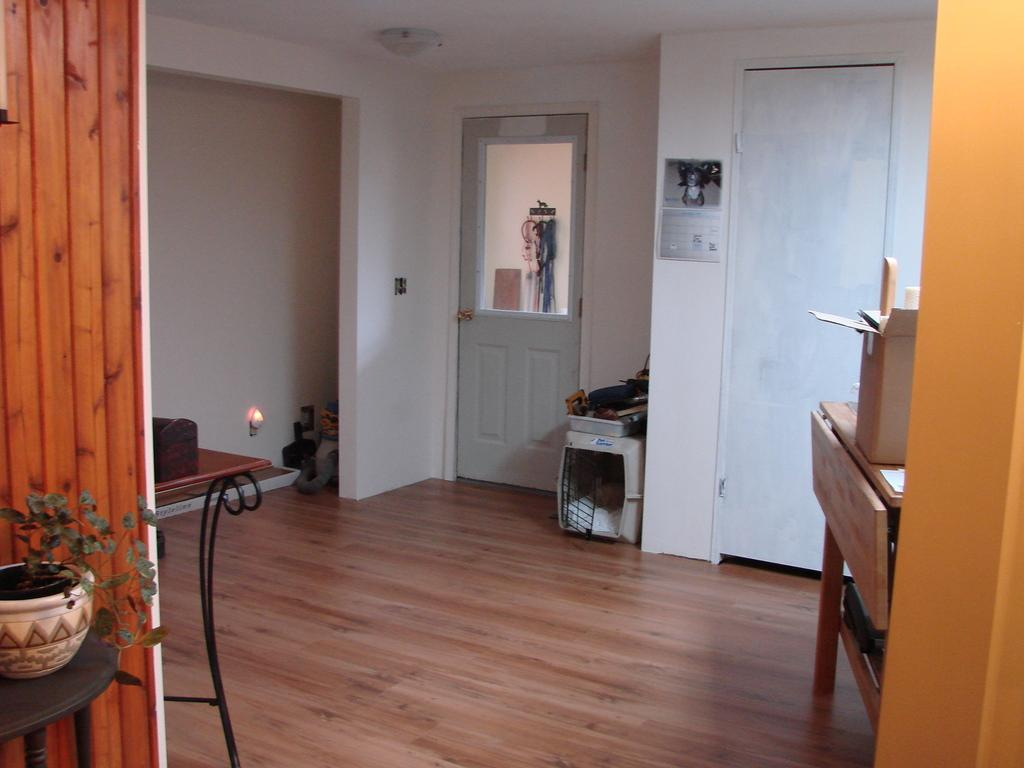What object is located in the bottom left side of the image? There is a plant pot in the bottom left side of the image. What type of architectural feature can be seen in the image? There are doors visible in the image. What furniture is present in the image? There are objects on a desk in the image. What else can be seen in the background of the image? There are other items in the background of the image. What type of dock can be seen in the image? There is no dock present in the image. What kind of ship is visible in the background of the image? There is no ship visible in the image. 